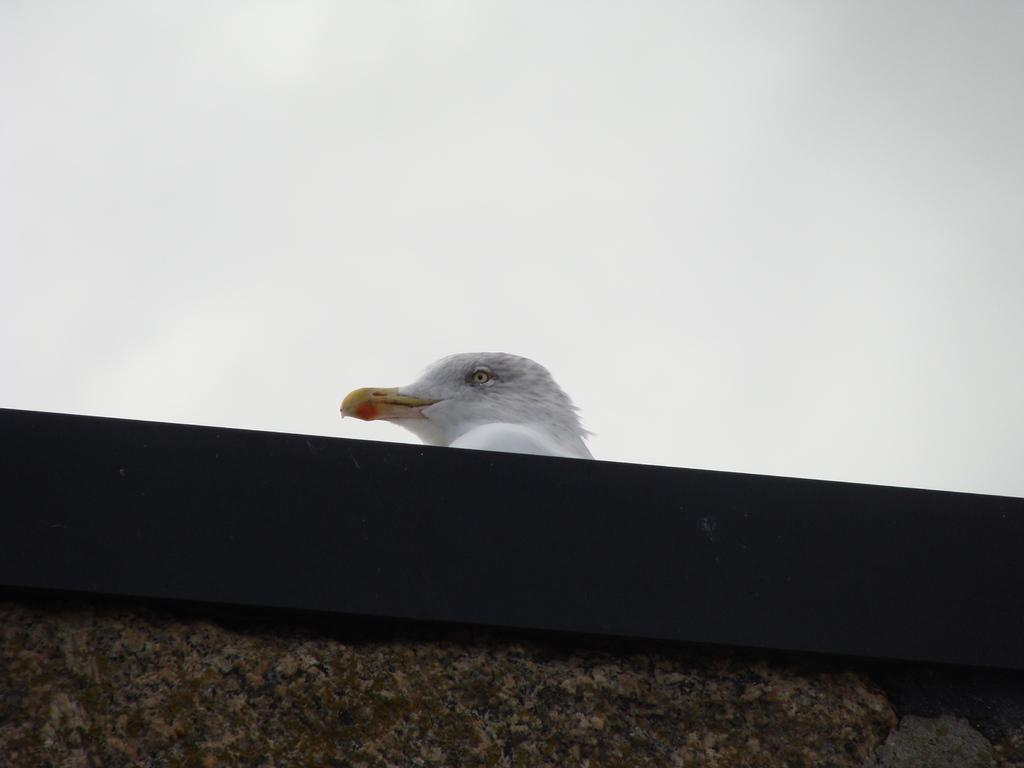What is the main object in the image? There is a black and brown colored object in the image. What part of the object has distinct colors? The bird's head in the image has white, black, and yellow colors. What is the color of the background in the image? The background of the image is white. What type of bubble can be seen in the image? There is no bubble present in the image. What does the loaf smell like in the image? There is no loaf present in the image, so it cannot be determined what it might smell like. 